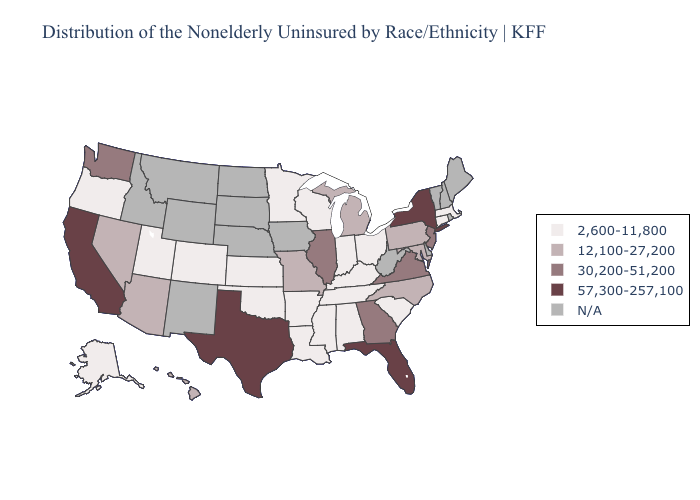Which states have the highest value in the USA?
Short answer required. California, Florida, New York, Texas. Does New Jersey have the highest value in the Northeast?
Answer briefly. No. What is the lowest value in the Northeast?
Concise answer only. 2,600-11,800. Name the states that have a value in the range 30,200-51,200?
Concise answer only. Georgia, Illinois, New Jersey, Virginia, Washington. Name the states that have a value in the range 2,600-11,800?
Answer briefly. Alabama, Alaska, Arkansas, Colorado, Connecticut, Indiana, Kansas, Kentucky, Louisiana, Massachusetts, Minnesota, Mississippi, Ohio, Oklahoma, Oregon, South Carolina, Tennessee, Utah, Wisconsin. What is the value of Nevada?
Write a very short answer. 12,100-27,200. Among the states that border Ohio , which have the highest value?
Concise answer only. Michigan, Pennsylvania. What is the value of Nevada?
Give a very brief answer. 12,100-27,200. Does the map have missing data?
Write a very short answer. Yes. What is the lowest value in states that border Nevada?
Concise answer only. 2,600-11,800. Does the first symbol in the legend represent the smallest category?
Concise answer only. Yes. Does Virginia have the lowest value in the South?
Write a very short answer. No. Name the states that have a value in the range N/A?
Keep it brief. Delaware, Idaho, Iowa, Maine, Montana, Nebraska, New Hampshire, New Mexico, North Dakota, Rhode Island, South Dakota, Vermont, West Virginia, Wyoming. 